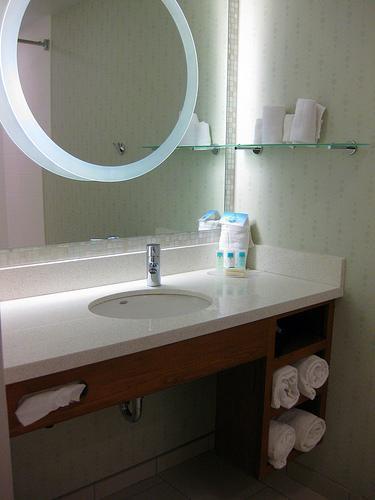How many towels are above the counter?
Give a very brief answer. 2. 